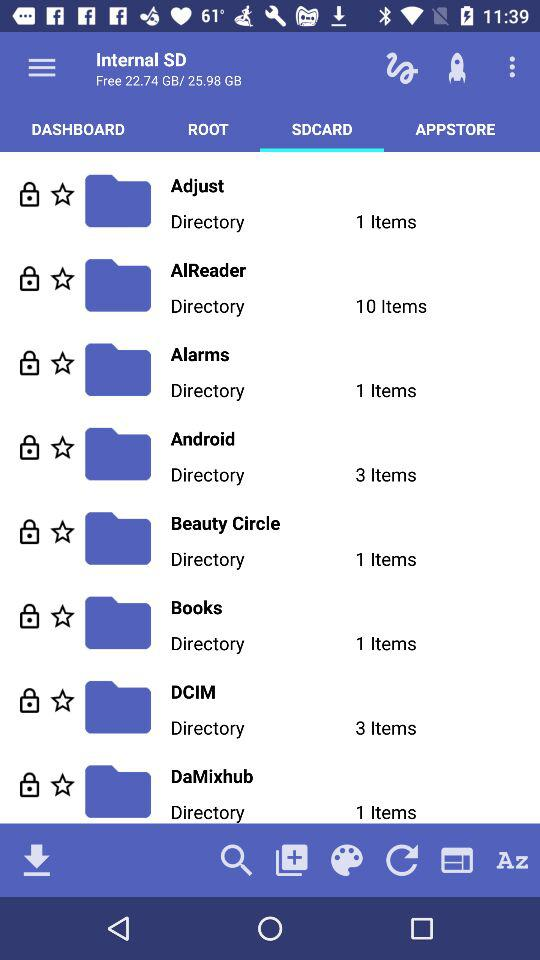How many items are in the directory Android?
Answer the question using a single word or phrase. 3 